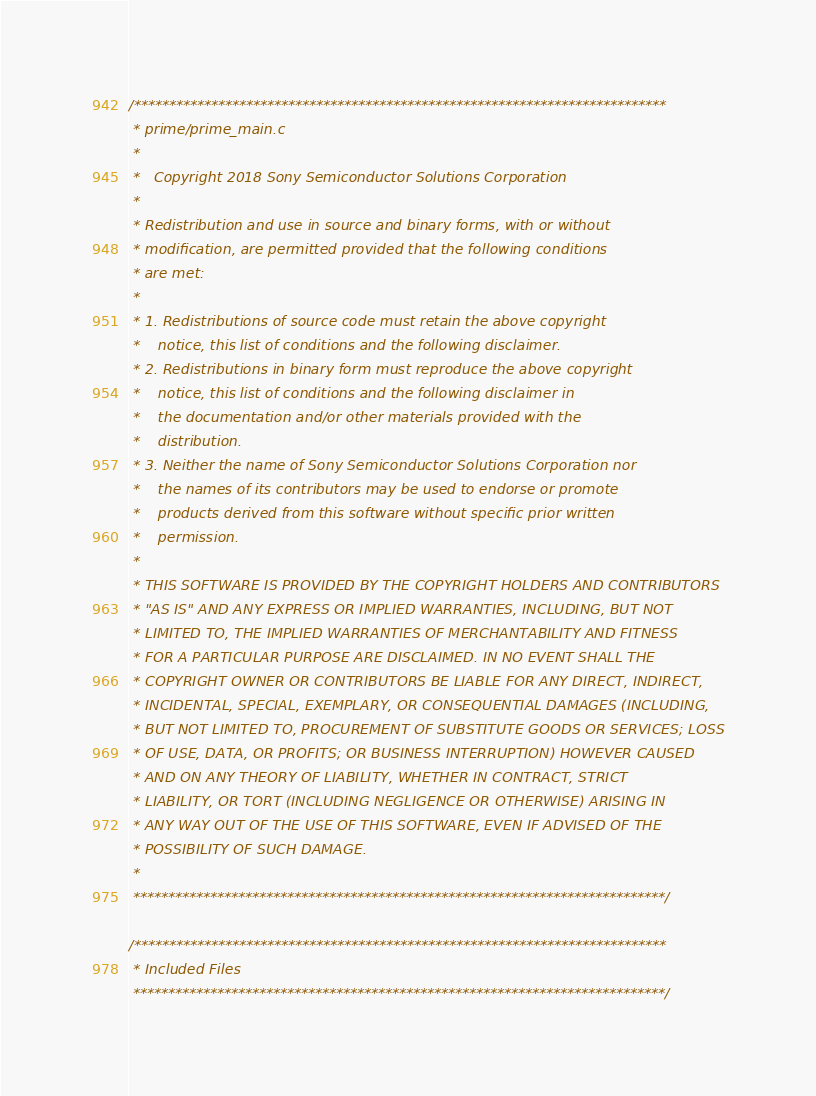<code> <loc_0><loc_0><loc_500><loc_500><_C_>/****************************************************************************
 * prime/prime_main.c
 *
 *   Copyright 2018 Sony Semiconductor Solutions Corporation
 *
 * Redistribution and use in source and binary forms, with or without
 * modification, are permitted provided that the following conditions
 * are met:
 *
 * 1. Redistributions of source code must retain the above copyright
 *    notice, this list of conditions and the following disclaimer.
 * 2. Redistributions in binary form must reproduce the above copyright
 *    notice, this list of conditions and the following disclaimer in
 *    the documentation and/or other materials provided with the
 *    distribution.
 * 3. Neither the name of Sony Semiconductor Solutions Corporation nor
 *    the names of its contributors may be used to endorse or promote
 *    products derived from this software without specific prior written
 *    permission.
 *
 * THIS SOFTWARE IS PROVIDED BY THE COPYRIGHT HOLDERS AND CONTRIBUTORS
 * "AS IS" AND ANY EXPRESS OR IMPLIED WARRANTIES, INCLUDING, BUT NOT
 * LIMITED TO, THE IMPLIED WARRANTIES OF MERCHANTABILITY AND FITNESS
 * FOR A PARTICULAR PURPOSE ARE DISCLAIMED. IN NO EVENT SHALL THE
 * COPYRIGHT OWNER OR CONTRIBUTORS BE LIABLE FOR ANY DIRECT, INDIRECT,
 * INCIDENTAL, SPECIAL, EXEMPLARY, OR CONSEQUENTIAL DAMAGES (INCLUDING,
 * BUT NOT LIMITED TO, PROCUREMENT OF SUBSTITUTE GOODS OR SERVICES; LOSS
 * OF USE, DATA, OR PROFITS; OR BUSINESS INTERRUPTION) HOWEVER CAUSED
 * AND ON ANY THEORY OF LIABILITY, WHETHER IN CONTRACT, STRICT
 * LIABILITY, OR TORT (INCLUDING NEGLIGENCE OR OTHERWISE) ARISING IN
 * ANY WAY OUT OF THE USE OF THIS SOFTWARE, EVEN IF ADVISED OF THE
 * POSSIBILITY OF SUCH DAMAGE.
 *
 ****************************************************************************/

/****************************************************************************
 * Included Files
 ****************************************************************************/
</code> 